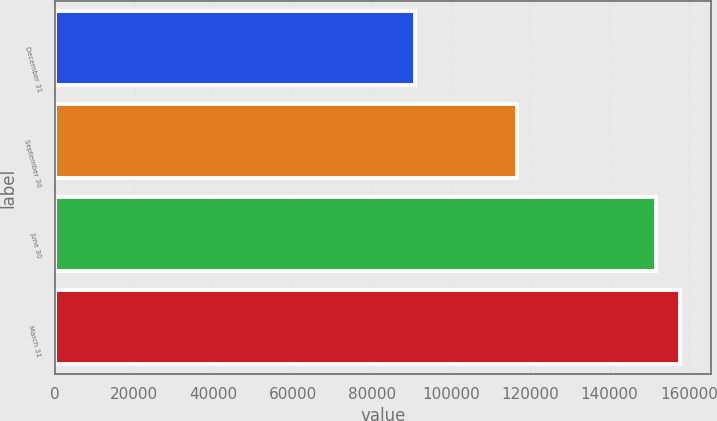Convert chart to OTSL. <chart><loc_0><loc_0><loc_500><loc_500><bar_chart><fcel>December 31<fcel>September 30<fcel>June 30<fcel>March 31<nl><fcel>90923<fcel>116546<fcel>151625<fcel>157796<nl></chart> 